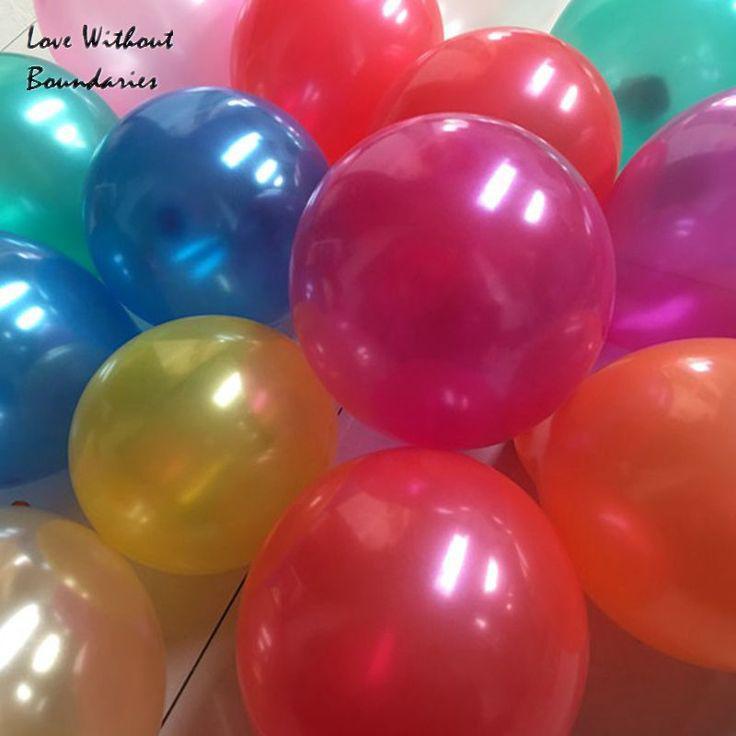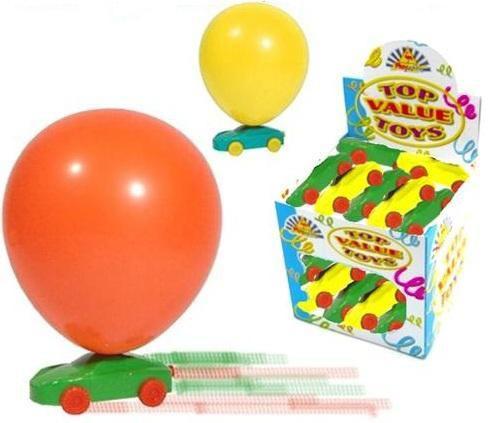The first image is the image on the left, the second image is the image on the right. Examine the images to the left and right. Is the description "One of the images shows a clown wearing a hat." accurate? Answer yes or no. No. 